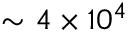Convert formula to latex. <formula><loc_0><loc_0><loc_500><loc_500>\sim 4 \times 1 0 ^ { 4 }</formula> 